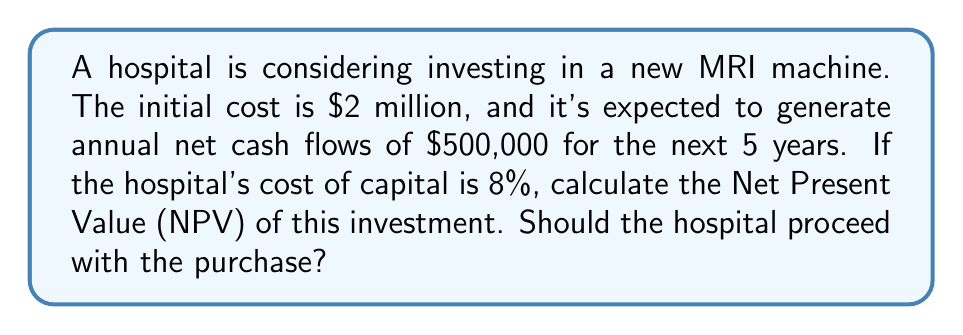Show me your answer to this math problem. To solve this problem, we'll use the Net Present Value (NPV) formula:

$$ NPV = -C_0 + \sum_{t=1}^n \frac{C_t}{(1+r)^t} $$

Where:
$C_0$ = Initial investment
$C_t$ = Cash flow at time t
$r$ = Discount rate (cost of capital)
$n$ = Number of periods

Step 1: Identify the given values
$C_0 = \$2,000,000$
$C_t = \$500,000$ (for t = 1 to 5)
$r = 8\% = 0.08$
$n = 5$ years

Step 2: Calculate the present value of each year's cash flow
Year 1: $\frac{500,000}{(1+0.08)^1} = 462,962.96$
Year 2: $\frac{500,000}{(1+0.08)^2} = 428,669.41$
Year 3: $\frac{500,000}{(1+0.08)^3} = 396,916.12$
Year 4: $\frac{500,000}{(1+0.08)^4} = 367,514.93$
Year 5: $\frac{500,000}{(1+0.08)^5} = 340,291.60$

Step 3: Sum the present values
$\sum_{t=1}^5 \frac{C_t}{(1+r)^t} = 1,996,355.02$

Step 4: Subtract the initial investment to get NPV
$NPV = -2,000,000 + 1,996,355.02 = -3,644.98$

Since the NPV is negative, the hospital should not proceed with the purchase as it does not add value to the organization.
Answer: $-\$3,644.98$; Do not proceed with the purchase. 